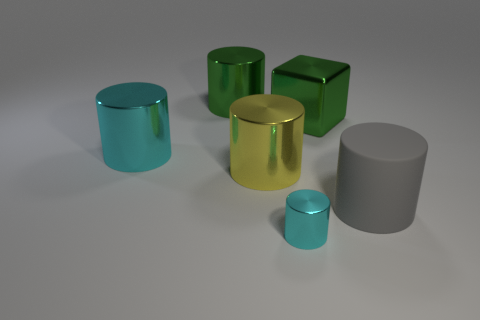What is the color of the tiny cylinder that is made of the same material as the cube?
Keep it short and to the point. Cyan. There is a big gray thing that is the same shape as the small thing; what is its material?
Keep it short and to the point. Rubber. What is the shape of the big cyan shiny object?
Give a very brief answer. Cylinder. The large cylinder that is behind the yellow object and to the right of the big cyan shiny cylinder is made of what material?
Your answer should be very brief. Metal. What shape is the green object that is made of the same material as the large green cylinder?
Your answer should be very brief. Cube. There is a green object that is made of the same material as the large block; what size is it?
Provide a succinct answer. Large. What shape is the metallic thing that is both in front of the big cyan thing and behind the big gray rubber thing?
Your response must be concise. Cylinder. What is the size of the shiny cylinder behind the cyan metal cylinder behind the large matte object?
Provide a short and direct response. Large. What number of other objects are the same color as the rubber cylinder?
Ensure brevity in your answer.  0. What is the big green block made of?
Provide a short and direct response. Metal. 